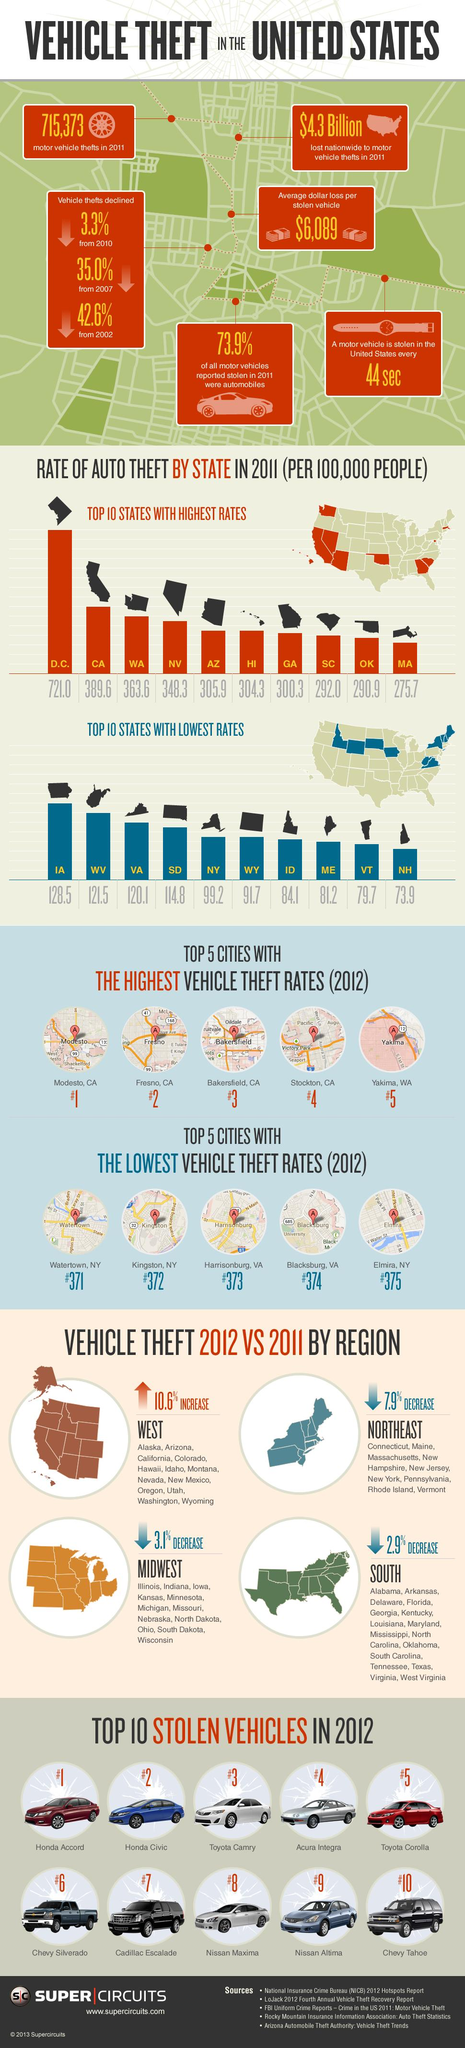Outline some significant characteristics in this image. California ranked second in the rate of theft in 2011. The Northeast region had the greatest decrease in vehicle theft from 2011 to 2012, as compared to the other regions. The Acura Integra was the fourth most commonly stolen vehicle in the United States. According to data from 2012, Stockton, California ranked fourth in terms of vehicle theft rates among all cities in the United States. 